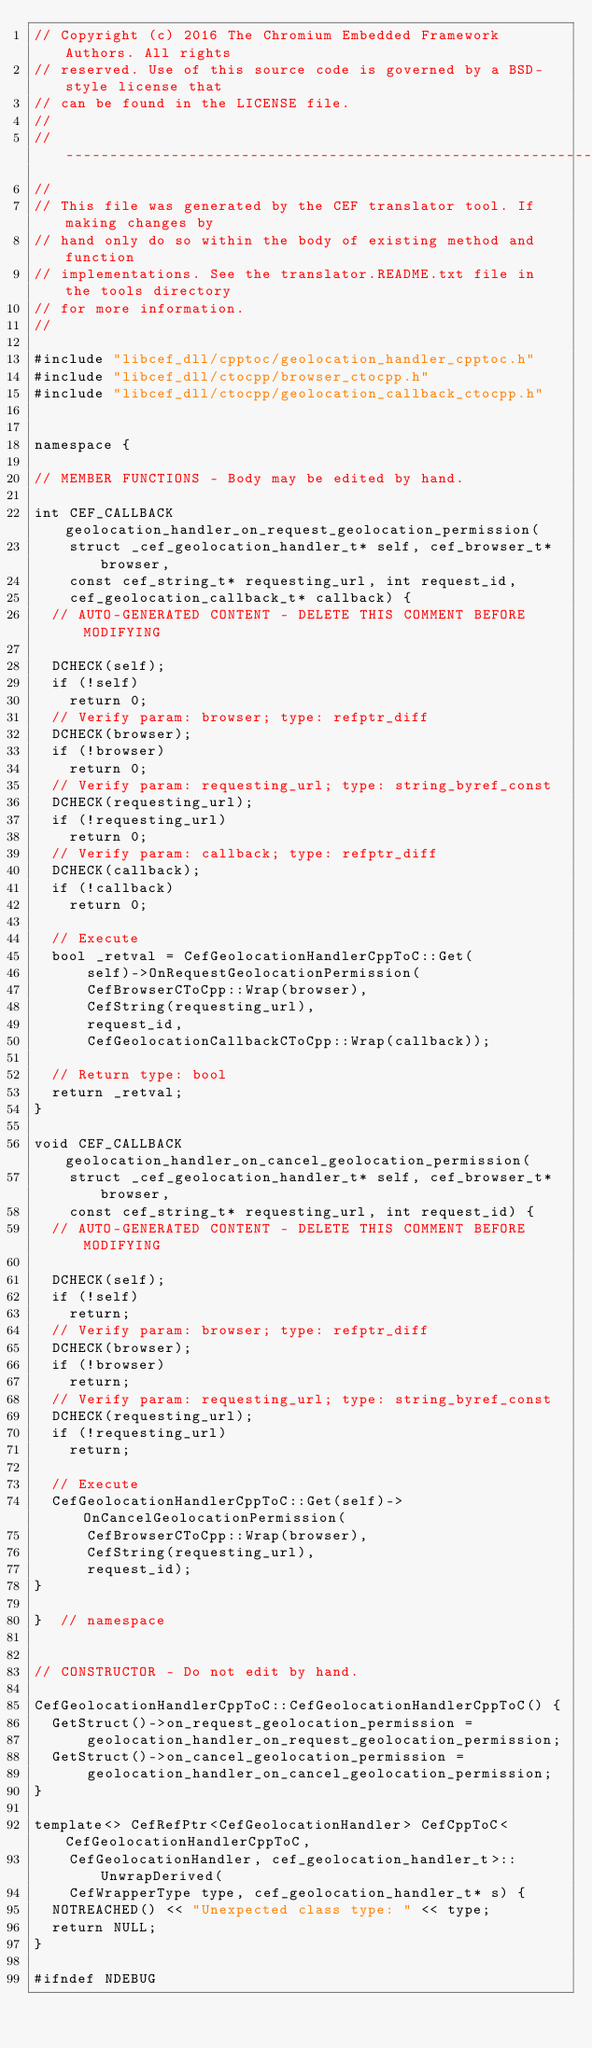Convert code to text. <code><loc_0><loc_0><loc_500><loc_500><_C++_>// Copyright (c) 2016 The Chromium Embedded Framework Authors. All rights
// reserved. Use of this source code is governed by a BSD-style license that
// can be found in the LICENSE file.
//
// ---------------------------------------------------------------------------
//
// This file was generated by the CEF translator tool. If making changes by
// hand only do so within the body of existing method and function
// implementations. See the translator.README.txt file in the tools directory
// for more information.
//

#include "libcef_dll/cpptoc/geolocation_handler_cpptoc.h"
#include "libcef_dll/ctocpp/browser_ctocpp.h"
#include "libcef_dll/ctocpp/geolocation_callback_ctocpp.h"


namespace {

// MEMBER FUNCTIONS - Body may be edited by hand.

int CEF_CALLBACK geolocation_handler_on_request_geolocation_permission(
    struct _cef_geolocation_handler_t* self, cef_browser_t* browser,
    const cef_string_t* requesting_url, int request_id,
    cef_geolocation_callback_t* callback) {
  // AUTO-GENERATED CONTENT - DELETE THIS COMMENT BEFORE MODIFYING

  DCHECK(self);
  if (!self)
    return 0;
  // Verify param: browser; type: refptr_diff
  DCHECK(browser);
  if (!browser)
    return 0;
  // Verify param: requesting_url; type: string_byref_const
  DCHECK(requesting_url);
  if (!requesting_url)
    return 0;
  // Verify param: callback; type: refptr_diff
  DCHECK(callback);
  if (!callback)
    return 0;

  // Execute
  bool _retval = CefGeolocationHandlerCppToC::Get(
      self)->OnRequestGeolocationPermission(
      CefBrowserCToCpp::Wrap(browser),
      CefString(requesting_url),
      request_id,
      CefGeolocationCallbackCToCpp::Wrap(callback));

  // Return type: bool
  return _retval;
}

void CEF_CALLBACK geolocation_handler_on_cancel_geolocation_permission(
    struct _cef_geolocation_handler_t* self, cef_browser_t* browser,
    const cef_string_t* requesting_url, int request_id) {
  // AUTO-GENERATED CONTENT - DELETE THIS COMMENT BEFORE MODIFYING

  DCHECK(self);
  if (!self)
    return;
  // Verify param: browser; type: refptr_diff
  DCHECK(browser);
  if (!browser)
    return;
  // Verify param: requesting_url; type: string_byref_const
  DCHECK(requesting_url);
  if (!requesting_url)
    return;

  // Execute
  CefGeolocationHandlerCppToC::Get(self)->OnCancelGeolocationPermission(
      CefBrowserCToCpp::Wrap(browser),
      CefString(requesting_url),
      request_id);
}

}  // namespace


// CONSTRUCTOR - Do not edit by hand.

CefGeolocationHandlerCppToC::CefGeolocationHandlerCppToC() {
  GetStruct()->on_request_geolocation_permission =
      geolocation_handler_on_request_geolocation_permission;
  GetStruct()->on_cancel_geolocation_permission =
      geolocation_handler_on_cancel_geolocation_permission;
}

template<> CefRefPtr<CefGeolocationHandler> CefCppToC<CefGeolocationHandlerCppToC,
    CefGeolocationHandler, cef_geolocation_handler_t>::UnwrapDerived(
    CefWrapperType type, cef_geolocation_handler_t* s) {
  NOTREACHED() << "Unexpected class type: " << type;
  return NULL;
}

#ifndef NDEBUG</code> 